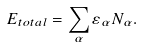Convert formula to latex. <formula><loc_0><loc_0><loc_500><loc_500>E _ { t o t a l } = \sum _ { \alpha } \varepsilon _ { \alpha } N _ { \alpha } .</formula> 